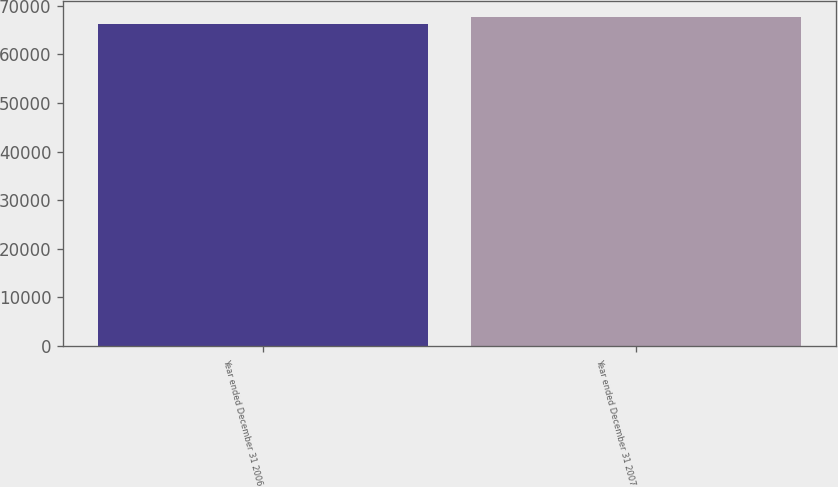Convert chart to OTSL. <chart><loc_0><loc_0><loc_500><loc_500><bar_chart><fcel>Year ended December 31 2006<fcel>Year ended December 31 2007<nl><fcel>66291<fcel>67661<nl></chart> 